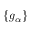<formula> <loc_0><loc_0><loc_500><loc_500>\{ g _ { \alpha } \}</formula> 